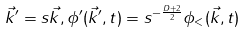Convert formula to latex. <formula><loc_0><loc_0><loc_500><loc_500>\vec { k } ^ { \prime } = s \vec { k } , \phi ^ { \prime } ( \vec { k } ^ { \prime } , t ) = s ^ { - \frac { D + 2 } { 2 } } \phi _ { < } ( \vec { k } , t )</formula> 